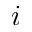Convert formula to latex. <formula><loc_0><loc_0><loc_500><loc_500>i</formula> 